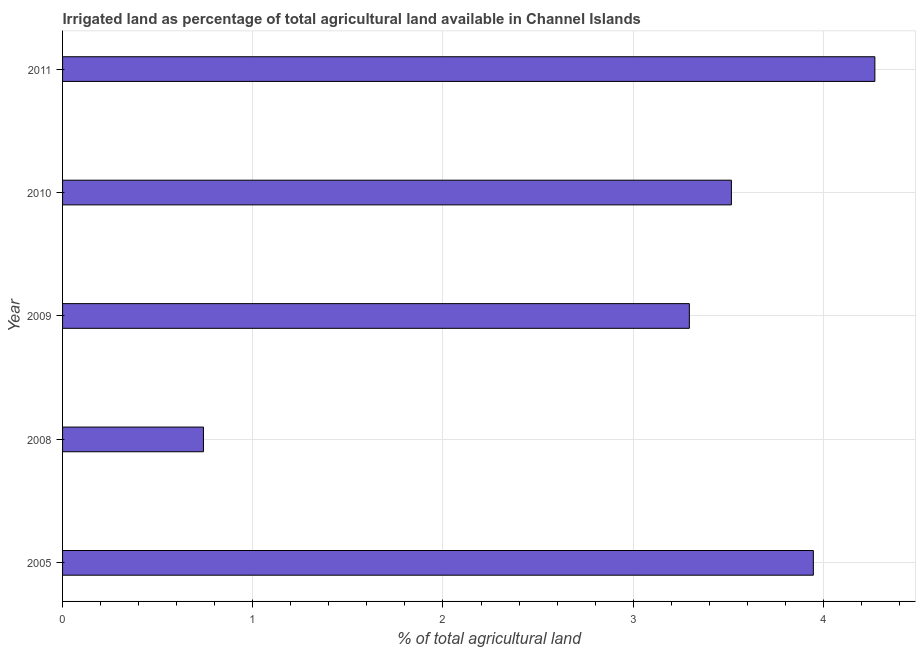Does the graph contain any zero values?
Ensure brevity in your answer.  No. Does the graph contain grids?
Your response must be concise. Yes. What is the title of the graph?
Your answer should be very brief. Irrigated land as percentage of total agricultural land available in Channel Islands. What is the label or title of the X-axis?
Ensure brevity in your answer.  % of total agricultural land. What is the percentage of agricultural irrigated land in 2008?
Offer a very short reply. 0.74. Across all years, what is the maximum percentage of agricultural irrigated land?
Give a very brief answer. 4.27. Across all years, what is the minimum percentage of agricultural irrigated land?
Ensure brevity in your answer.  0.74. In which year was the percentage of agricultural irrigated land maximum?
Your answer should be compact. 2011. What is the sum of the percentage of agricultural irrigated land?
Make the answer very short. 15.77. What is the difference between the percentage of agricultural irrigated land in 2005 and 2009?
Offer a terse response. 0.65. What is the average percentage of agricultural irrigated land per year?
Provide a succinct answer. 3.15. What is the median percentage of agricultural irrigated land?
Offer a very short reply. 3.52. What is the ratio of the percentage of agricultural irrigated land in 2008 to that in 2009?
Offer a very short reply. 0.23. What is the difference between the highest and the second highest percentage of agricultural irrigated land?
Your answer should be very brief. 0.32. What is the difference between the highest and the lowest percentage of agricultural irrigated land?
Offer a terse response. 3.53. Are the values on the major ticks of X-axis written in scientific E-notation?
Offer a very short reply. No. What is the % of total agricultural land of 2005?
Keep it short and to the point. 3.95. What is the % of total agricultural land in 2008?
Keep it short and to the point. 0.74. What is the % of total agricultural land of 2009?
Provide a short and direct response. 3.3. What is the % of total agricultural land in 2010?
Your answer should be very brief. 3.52. What is the % of total agricultural land in 2011?
Give a very brief answer. 4.27. What is the difference between the % of total agricultural land in 2005 and 2008?
Provide a short and direct response. 3.21. What is the difference between the % of total agricultural land in 2005 and 2009?
Give a very brief answer. 0.65. What is the difference between the % of total agricultural land in 2005 and 2010?
Your answer should be very brief. 0.43. What is the difference between the % of total agricultural land in 2005 and 2011?
Make the answer very short. -0.32. What is the difference between the % of total agricultural land in 2008 and 2009?
Give a very brief answer. -2.55. What is the difference between the % of total agricultural land in 2008 and 2010?
Provide a succinct answer. -2.78. What is the difference between the % of total agricultural land in 2008 and 2011?
Your answer should be compact. -3.53. What is the difference between the % of total agricultural land in 2009 and 2010?
Ensure brevity in your answer.  -0.22. What is the difference between the % of total agricultural land in 2009 and 2011?
Provide a short and direct response. -0.98. What is the difference between the % of total agricultural land in 2010 and 2011?
Ensure brevity in your answer.  -0.75. What is the ratio of the % of total agricultural land in 2005 to that in 2008?
Offer a terse response. 5.33. What is the ratio of the % of total agricultural land in 2005 to that in 2009?
Make the answer very short. 1.2. What is the ratio of the % of total agricultural land in 2005 to that in 2010?
Your response must be concise. 1.12. What is the ratio of the % of total agricultural land in 2005 to that in 2011?
Keep it short and to the point. 0.92. What is the ratio of the % of total agricultural land in 2008 to that in 2009?
Your answer should be very brief. 0.23. What is the ratio of the % of total agricultural land in 2008 to that in 2010?
Your response must be concise. 0.21. What is the ratio of the % of total agricultural land in 2008 to that in 2011?
Offer a very short reply. 0.17. What is the ratio of the % of total agricultural land in 2009 to that in 2010?
Give a very brief answer. 0.94. What is the ratio of the % of total agricultural land in 2009 to that in 2011?
Your response must be concise. 0.77. What is the ratio of the % of total agricultural land in 2010 to that in 2011?
Keep it short and to the point. 0.82. 